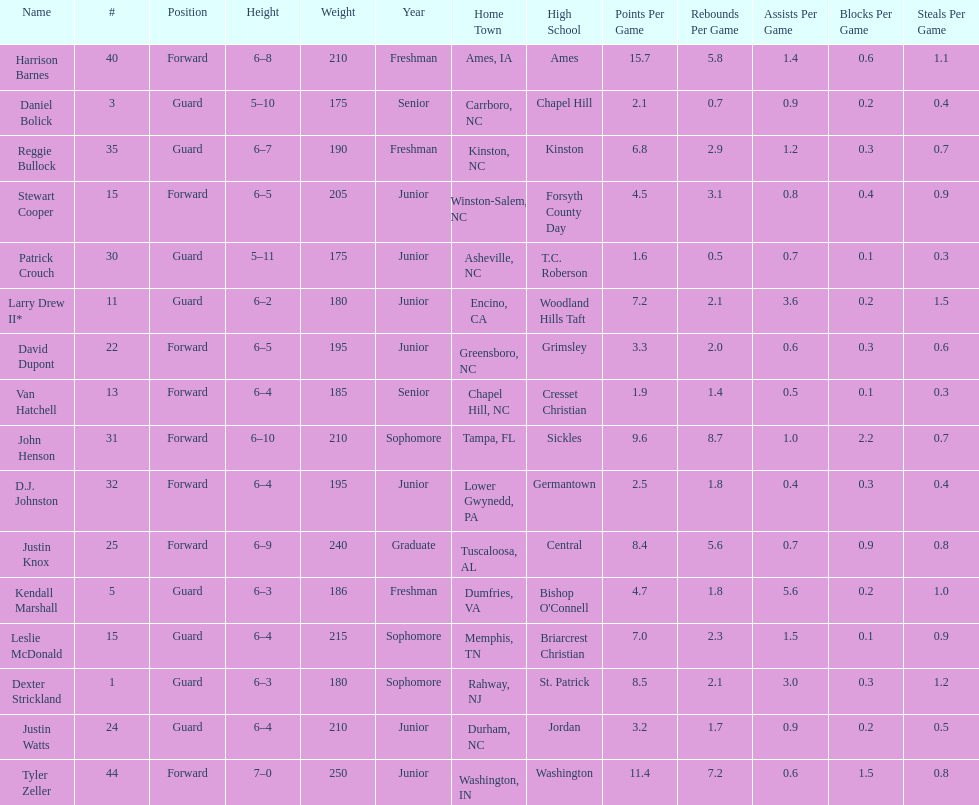How many players are not a junior? 9. Would you be able to parse every entry in this table? {'header': ['Name', '#', 'Position', 'Height', 'Weight', 'Year', 'Home Town', 'High School', 'Points Per Game', 'Rebounds Per Game', 'Assists Per Game', 'Blocks Per Game', 'Steals Per Game'], 'rows': [['Harrison Barnes', '40', 'Forward', '6–8', '210', 'Freshman', 'Ames, IA', 'Ames', '15.7', '5.8', '1.4', '0.6', '1.1'], ['Daniel Bolick', '3', 'Guard', '5–10', '175', 'Senior', 'Carrboro, NC', 'Chapel Hill', '2.1', '0.7', '0.9', '0.2', '0.4'], ['Reggie Bullock', '35', 'Guard', '6–7', '190', 'Freshman', 'Kinston, NC', 'Kinston', '6.8', '2.9', '1.2', '0.3', '0.7'], ['Stewart Cooper', '15', 'Forward', '6–5', '205', 'Junior', 'Winston-Salem, NC', 'Forsyth County Day', '4.5', '3.1', '0.8', '0.4', '0.9'], ['Patrick Crouch', '30', 'Guard', '5–11', '175', 'Junior', 'Asheville, NC', 'T.C. Roberson', '1.6', '0.5', '0.7', '0.1', '0.3'], ['Larry Drew II*', '11', 'Guard', '6–2', '180', 'Junior', 'Encino, CA', 'Woodland Hills Taft', '7.2', '2.1', '3.6', '0.2', '1.5'], ['David Dupont', '22', 'Forward', '6–5', '195', 'Junior', 'Greensboro, NC', 'Grimsley', '3.3', '2.0', '0.6', '0.3', '0.6'], ['Van Hatchell', '13', 'Forward', '6–4', '185', 'Senior', 'Chapel Hill, NC', 'Cresset Christian', '1.9', '1.4', '0.5', '0.1', '0.3'], ['John Henson', '31', 'Forward', '6–10', '210', 'Sophomore', 'Tampa, FL', 'Sickles', '9.6', '8.7', '1.0', '2.2', '0.7'], ['D.J. Johnston', '32', 'Forward', '6–4', '195', 'Junior', 'Lower Gwynedd, PA', 'Germantown', '2.5', '1.8', '0.4', '0.3', '0.4'], ['Justin Knox', '25', 'Forward', '6–9', '240', 'Graduate', 'Tuscaloosa, AL', 'Central', '8.4', '5.6', '0.7', '0.9', '0.8'], ['Kendall Marshall', '5', 'Guard', '6–3', '186', 'Freshman', 'Dumfries, VA', "Bishop O'Connell", '4.7', '1.8', '5.6', '0.2', '1.0'], ['Leslie McDonald', '15', 'Guard', '6–4', '215', 'Sophomore', 'Memphis, TN', 'Briarcrest Christian', '7.0', '2.3', '1.5', '0.1', '0.9'], ['Dexter Strickland', '1', 'Guard', '6–3', '180', 'Sophomore', 'Rahway, NJ', 'St. Patrick', '8.5', '2.1', '3.0', '0.3', '1.2'], ['Justin Watts', '24', 'Guard', '6–4', '210', 'Junior', 'Durham, NC', 'Jordan', '3.2', '1.7', '0.9', '0.2', '0.5'], ['Tyler Zeller', '44', 'Forward', '7–0', '250', 'Junior', 'Washington, IN', 'Washington', '11.4', '7.2', '0.6', '1.5', '0.8']]} 